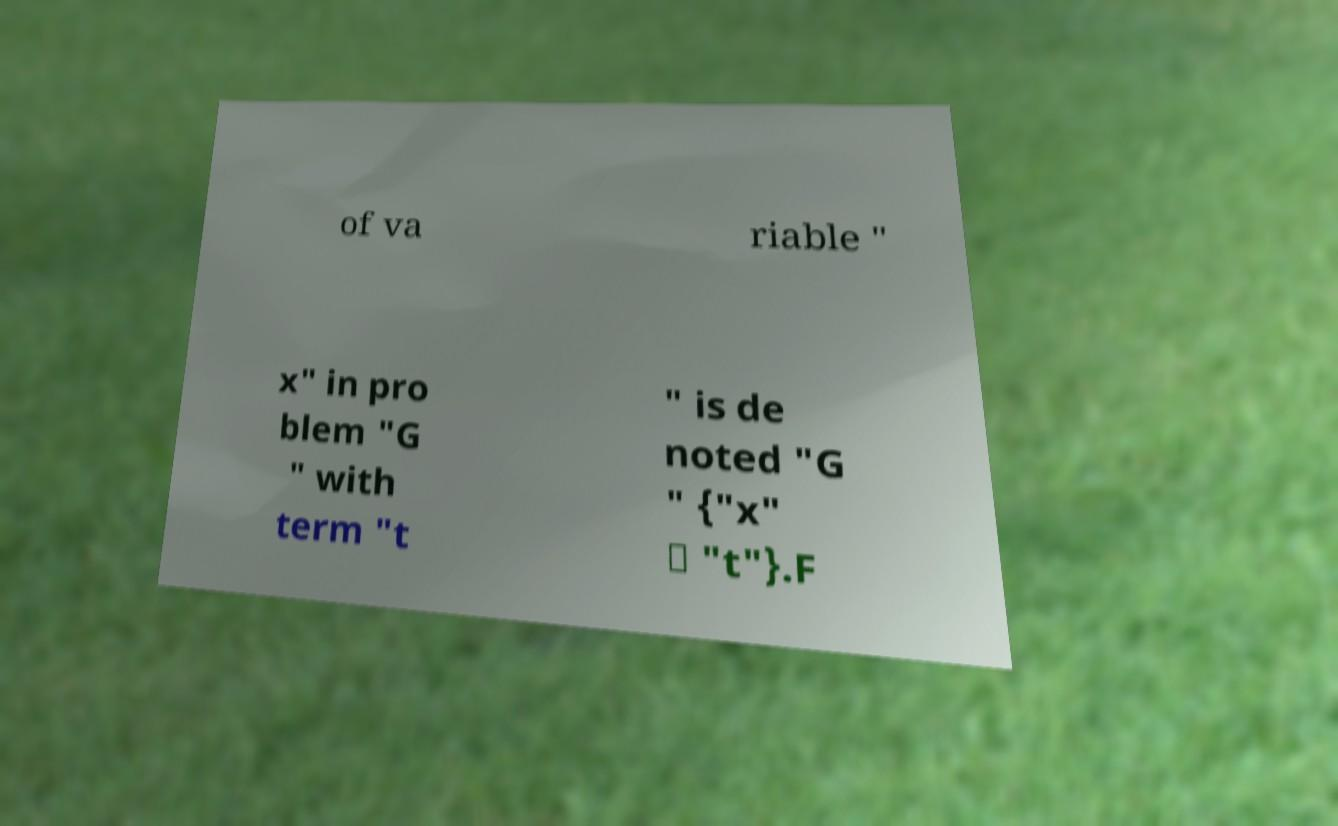Please identify and transcribe the text found in this image. of va riable " x" in pro blem "G " with term "t " is de noted "G " {"x" ↦ "t"}.F 